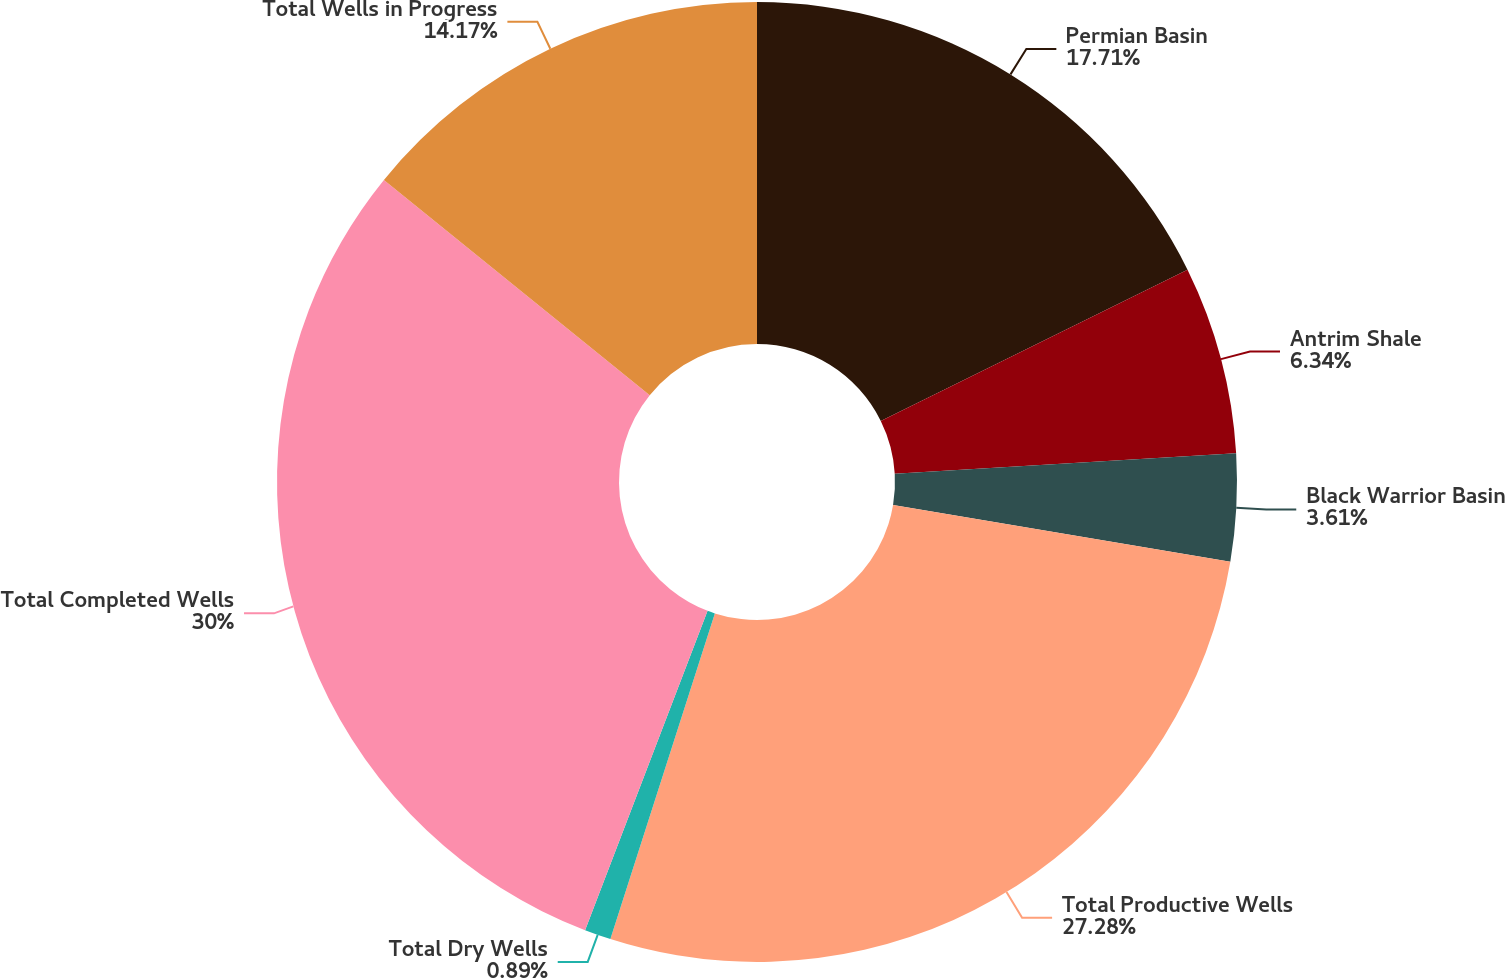<chart> <loc_0><loc_0><loc_500><loc_500><pie_chart><fcel>Permian Basin<fcel>Antrim Shale<fcel>Black Warrior Basin<fcel>Total Productive Wells<fcel>Total Dry Wells<fcel>Total Completed Wells<fcel>Total Wells in Progress<nl><fcel>17.71%<fcel>6.34%<fcel>3.61%<fcel>27.28%<fcel>0.89%<fcel>30.0%<fcel>14.17%<nl></chart> 